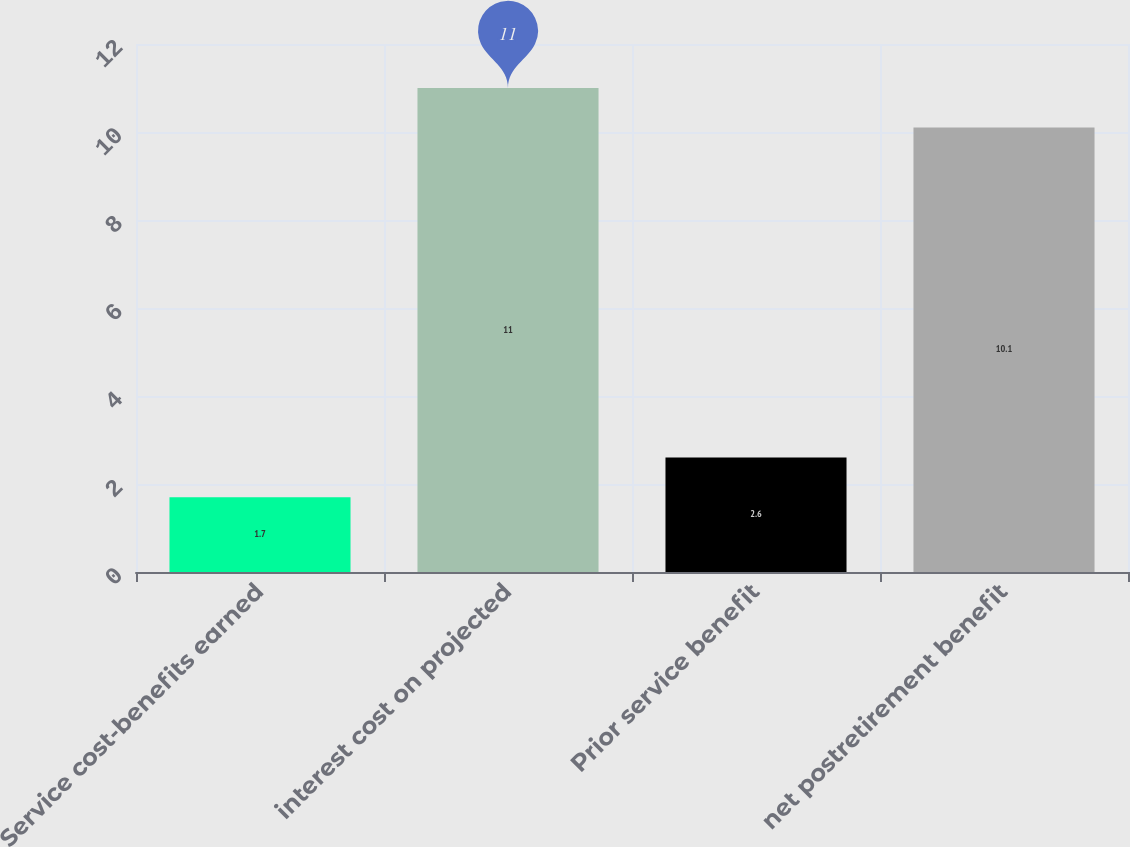Convert chart. <chart><loc_0><loc_0><loc_500><loc_500><bar_chart><fcel>Service cost-benefits earned<fcel>interest cost on projected<fcel>Prior service benefit<fcel>net postretirement benefit<nl><fcel>1.7<fcel>11<fcel>2.6<fcel>10.1<nl></chart> 